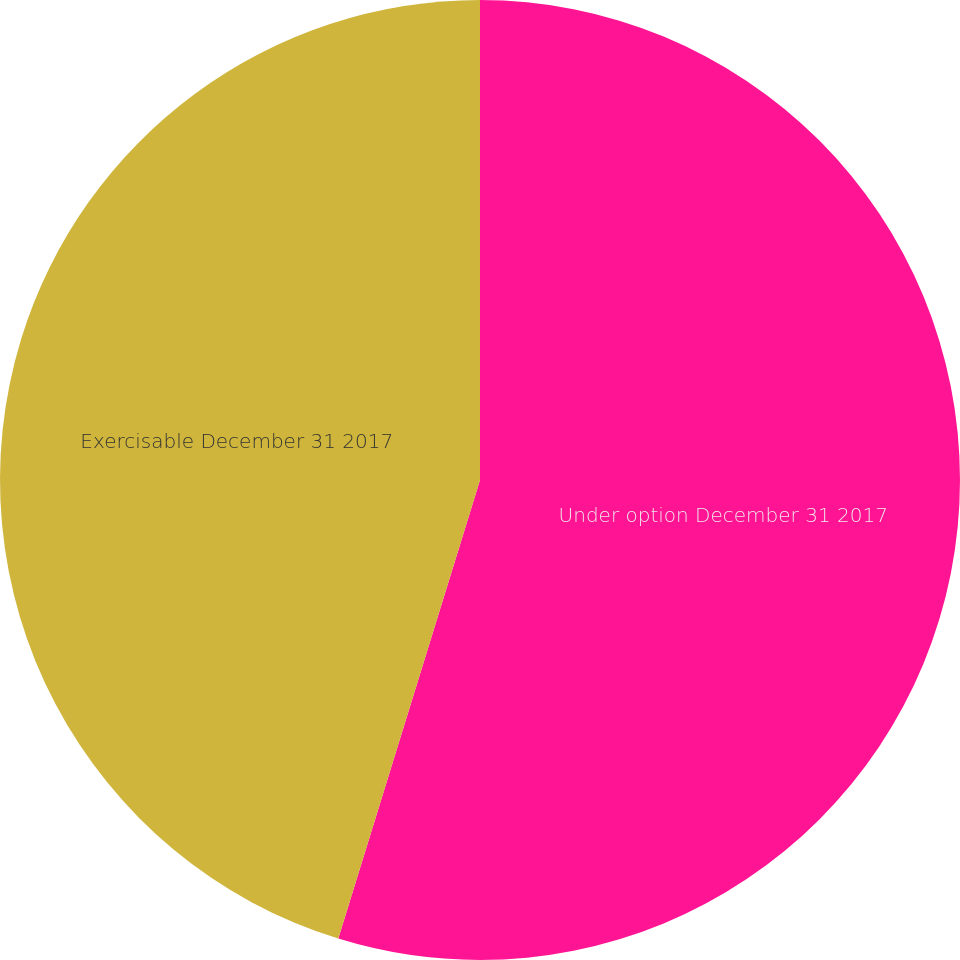Convert chart to OTSL. <chart><loc_0><loc_0><loc_500><loc_500><pie_chart><fcel>Under option December 31 2017<fcel>Exercisable December 31 2017<nl><fcel>54.77%<fcel>45.23%<nl></chart> 